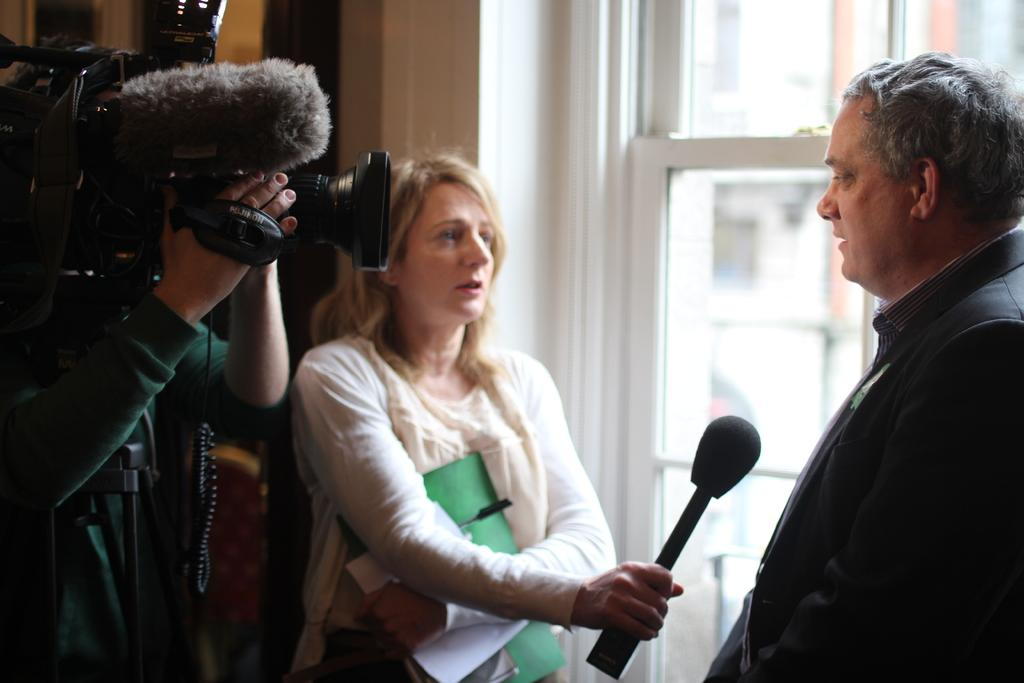What is the person on the right side of the image doing? The person is standing and speaking. Can you describe the position of the woman in relation to the person? The woman is in front of the person. What is the woman holding in her right hand? The woman is holding a microphone in her right hand. Who else is present in the image? There is a camera man beside the woman. What type of zinc is being used to hold the microphone in the image? There is no zinc present in the image; the woman is holding a microphone with her hand. 